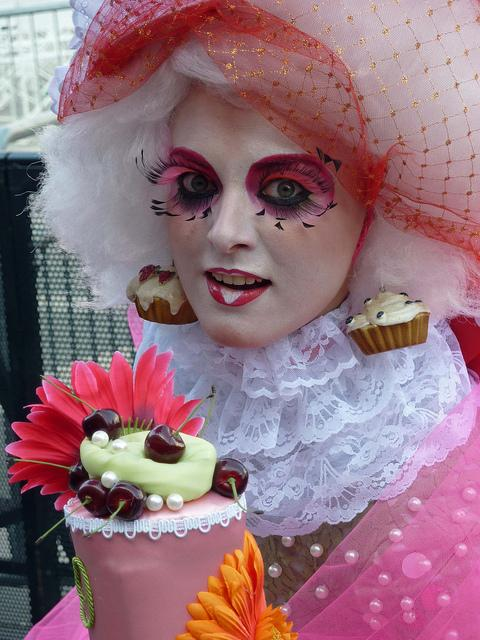What stuff in the photo is edible? cherry 